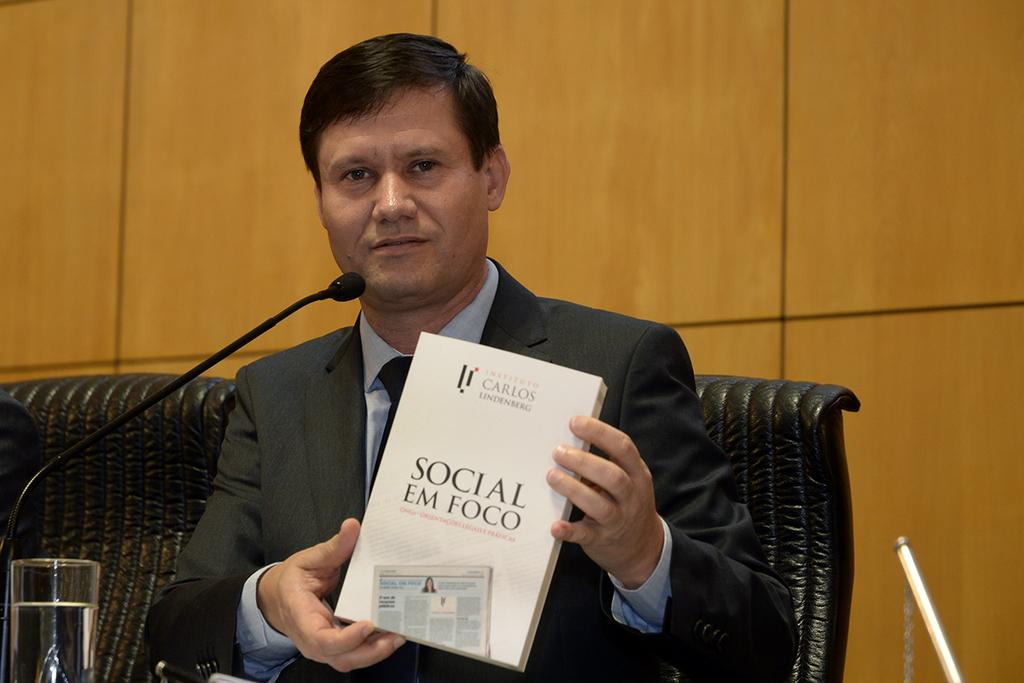Provide a one-sentence caption for the provided image. A seated man holds a copy of Social Em Foco in his hands. 